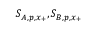<formula> <loc_0><loc_0><loc_500><loc_500>S _ { A , p , x _ { + } } , S _ { B , p , x _ { + } }</formula> 